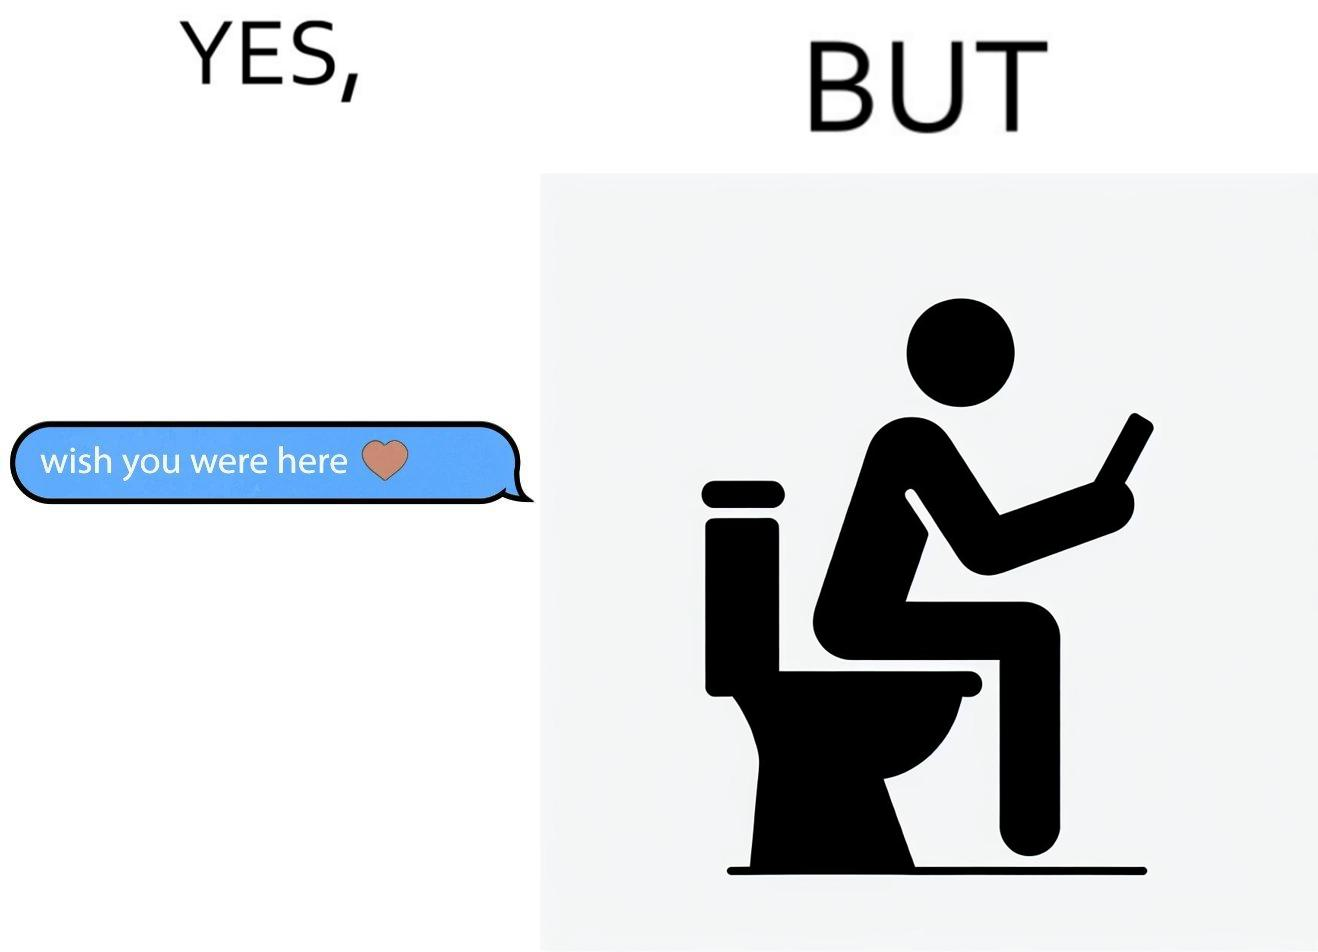What is shown in the left half versus the right half of this image? In the left part of the image: It is a text saying "i wish you were here" indicating that someone is missing their partner In the right part of the image: It is a man using his phone while using a toilet 